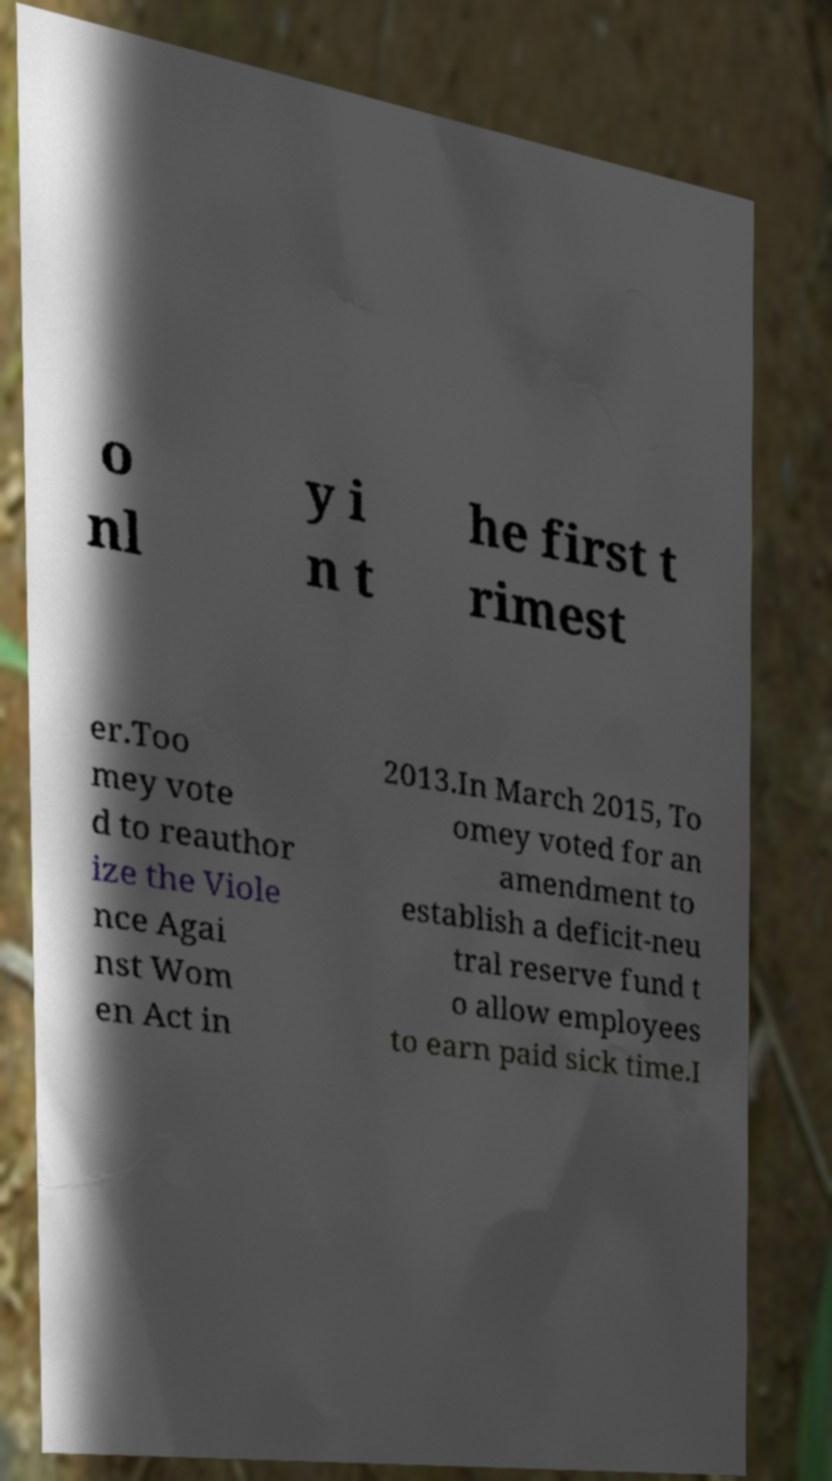Can you accurately transcribe the text from the provided image for me? o nl y i n t he first t rimest er.Too mey vote d to reauthor ize the Viole nce Agai nst Wom en Act in 2013.In March 2015, To omey voted for an amendment to establish a deficit-neu tral reserve fund t o allow employees to earn paid sick time.I 